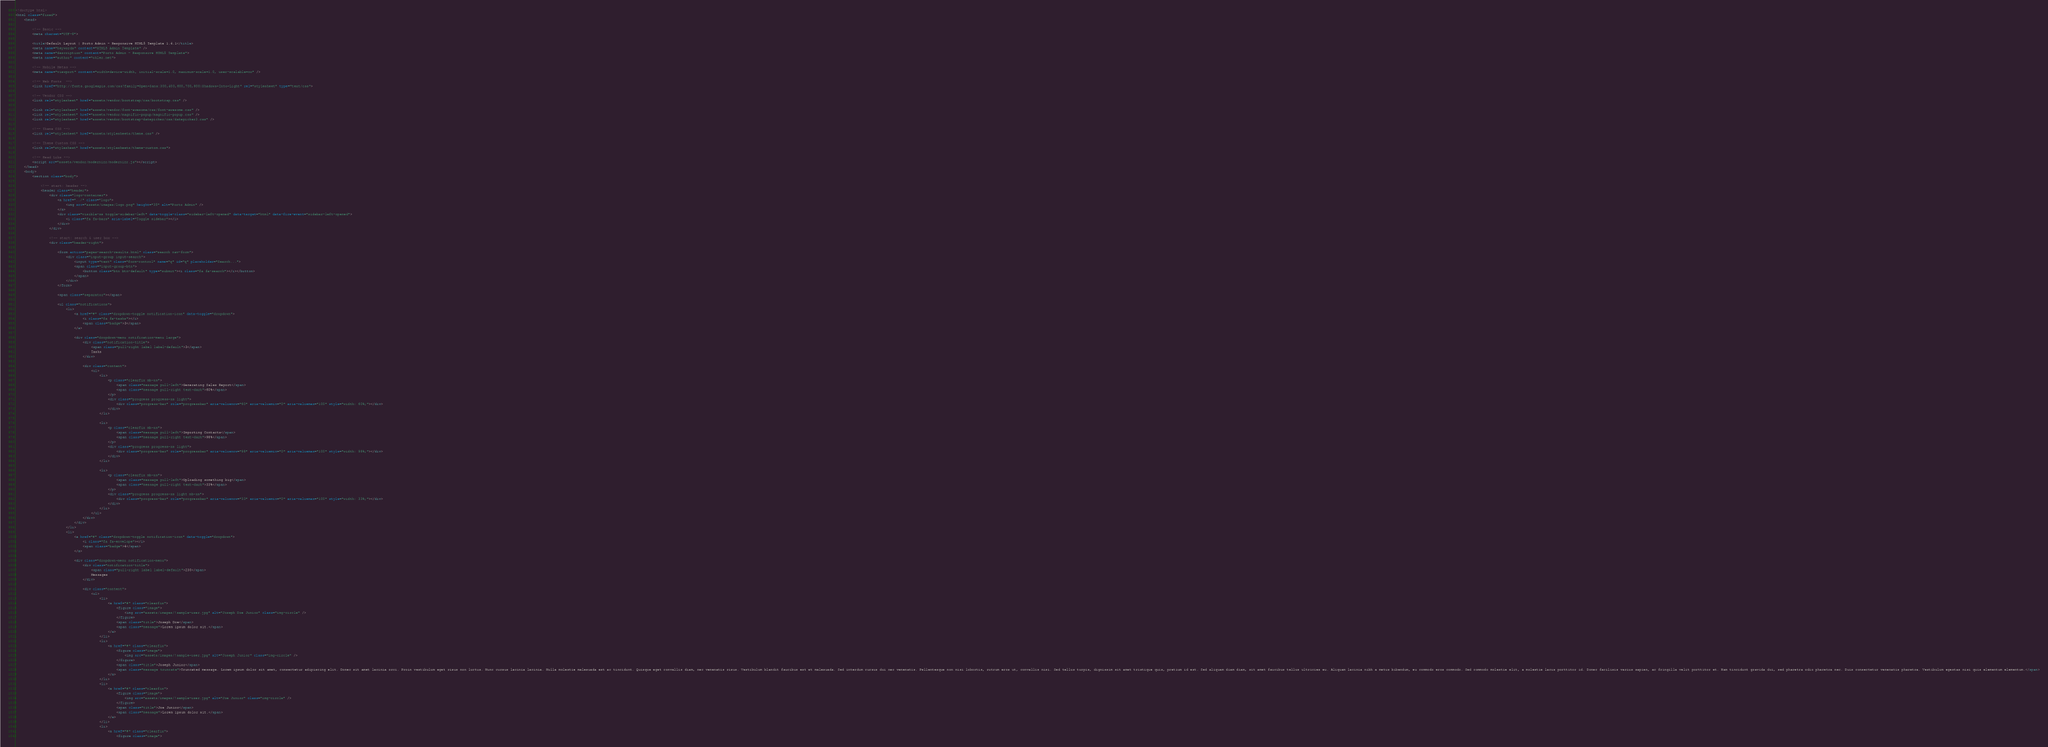Convert code to text. <code><loc_0><loc_0><loc_500><loc_500><_HTML_><!doctype html>
<html class="fixed">
	<head>

		<!-- Basic -->
		<meta charset="UTF-8">

		<title>Default Layout | Porto Admin - Responsive HTML5 Template 1.4.1</title>
		<meta name="keywords" content="HTML5 Admin Template" />
		<meta name="description" content="Porto Admin - Responsive HTML5 Template">
		<meta name="author" content="okler.net">

		<!-- Mobile Metas -->
		<meta name="viewport" content="width=device-width, initial-scale=1.0, maximum-scale=1.0, user-scalable=no" />

		<!-- Web Fonts  -->
		<link href="http://fonts.googleapis.com/css?family=Open+Sans:300,400,600,700,800|Shadows+Into+Light" rel="stylesheet" type="text/css">

		<!-- Vendor CSS -->
		<link rel="stylesheet" href="assets/vendor/bootstrap/css/bootstrap.css" />

		<link rel="stylesheet" href="assets/vendor/font-awesome/css/font-awesome.css" />
		<link rel="stylesheet" href="assets/vendor/magnific-popup/magnific-popup.css" />
		<link rel="stylesheet" href="assets/vendor/bootstrap-datepicker/css/datepicker3.css" />

		<!-- Theme CSS -->
		<link rel="stylesheet" href="assets/stylesheets/theme.css" />

		<!-- Theme Custom CSS -->
		<link rel="stylesheet" href="assets/stylesheets/theme-custom.css">

		<!-- Head Libs -->
		<script src="assets/vendor/modernizr/modernizr.js"></script>
	</head>
	<body>
		<section class="body">

			<!-- start: header -->
			<header class="header">
				<div class="logo-container">
					<a href="../" class="logo">
						<img src="assets/images/logo.png" height="35" alt="Porto Admin" />
					</a>
					<div class="visible-xs toggle-sidebar-left" data-toggle-class="sidebar-left-opened" data-target="html" data-fire-event="sidebar-left-opened">
						<i class="fa fa-bars" aria-label="Toggle sidebar"></i>
					</div>
				</div>
			
				<!-- start: search & user box -->
				<div class="header-right">
			
					<form action="pages-search-results.html" class="search nav-form">
						<div class="input-group input-search">
							<input type="text" class="form-control" name="q" id="q" placeholder="Search...">
							<span class="input-group-btn">
								<button class="btn btn-default" type="submit"><i class="fa fa-search"></i></button>
							</span>
						</div>
					</form>
			
					<span class="separator"></span>
			
					<ul class="notifications">
						<li>
							<a href="#" class="dropdown-toggle notification-icon" data-toggle="dropdown">
								<i class="fa fa-tasks"></i>
								<span class="badge">3</span>
							</a>
			
							<div class="dropdown-menu notification-menu large">
								<div class="notification-title">
									<span class="pull-right label label-default">3</span>
									Tasks
								</div>
			
								<div class="content">
									<ul>
										<li>
											<p class="clearfix mb-xs">
												<span class="message pull-left">Generating Sales Report</span>
												<span class="message pull-right text-dark">60%</span>
											</p>
											<div class="progress progress-xs light">
												<div class="progress-bar" role="progressbar" aria-valuenow="60" aria-valuemin="0" aria-valuemax="100" style="width: 60%;"></div>
											</div>
										</li>
			
										<li>
											<p class="clearfix mb-xs">
												<span class="message pull-left">Importing Contacts</span>
												<span class="message pull-right text-dark">98%</span>
											</p>
											<div class="progress progress-xs light">
												<div class="progress-bar" role="progressbar" aria-valuenow="98" aria-valuemin="0" aria-valuemax="100" style="width: 98%;"></div>
											</div>
										</li>
			
										<li>
											<p class="clearfix mb-xs">
												<span class="message pull-left">Uploading something big</span>
												<span class="message pull-right text-dark">33%</span>
											</p>
											<div class="progress progress-xs light mb-xs">
												<div class="progress-bar" role="progressbar" aria-valuenow="33" aria-valuemin="0" aria-valuemax="100" style="width: 33%;"></div>
											</div>
										</li>
									</ul>
								</div>
							</div>
						</li>
						<li>
							<a href="#" class="dropdown-toggle notification-icon" data-toggle="dropdown">
								<i class="fa fa-envelope"></i>
								<span class="badge">4</span>
							</a>
			
							<div class="dropdown-menu notification-menu">
								<div class="notification-title">
									<span class="pull-right label label-default">230</span>
									Messages
								</div>
			
								<div class="content">
									<ul>
										<li>
											<a href="#" class="clearfix">
												<figure class="image">
													<img src="assets/images/!sample-user.jpg" alt="Joseph Doe Junior" class="img-circle" />
												</figure>
												<span class="title">Joseph Doe</span>
												<span class="message">Lorem ipsum dolor sit.</span>
											</a>
										</li>
										<li>
											<a href="#" class="clearfix">
												<figure class="image">
													<img src="assets/images/!sample-user.jpg" alt="Joseph Junior" class="img-circle" />
												</figure>
												<span class="title">Joseph Junior</span>
												<span class="message truncate">Truncated message. Lorem ipsum dolor sit amet, consectetur adipiscing elit. Donec sit amet lacinia orci. Proin vestibulum eget risus non luctus. Nunc cursus lacinia lacinia. Nulla molestie malesuada est ac tincidunt. Quisque eget convallis diam, nec venenatis risus. Vestibulum blandit faucibus est et malesuada. Sed interdum cursus dui nec venenatis. Pellentesque non nisi lobortis, rutrum eros ut, convallis nisi. Sed tellus turpis, dignissim sit amet tristique quis, pretium id est. Sed aliquam diam diam, sit amet faucibus tellus ultricies eu. Aliquam lacinia nibh a metus bibendum, eu commodo eros commodo. Sed commodo molestie elit, a molestie lacus porttitor id. Donec facilisis varius sapien, ac fringilla velit porttitor et. Nam tincidunt gravida dui, sed pharetra odio pharetra nec. Duis consectetur venenatis pharetra. Vestibulum egestas nisi quis elementum elementum.</span>
											</a>
										</li>
										<li>
											<a href="#" class="clearfix">
												<figure class="image">
													<img src="assets/images/!sample-user.jpg" alt="Joe Junior" class="img-circle" />
												</figure>
												<span class="title">Joe Junior</span>
												<span class="message">Lorem ipsum dolor sit.</span>
											</a>
										</li>
										<li>
											<a href="#" class="clearfix">
												<figure class="image"></code> 